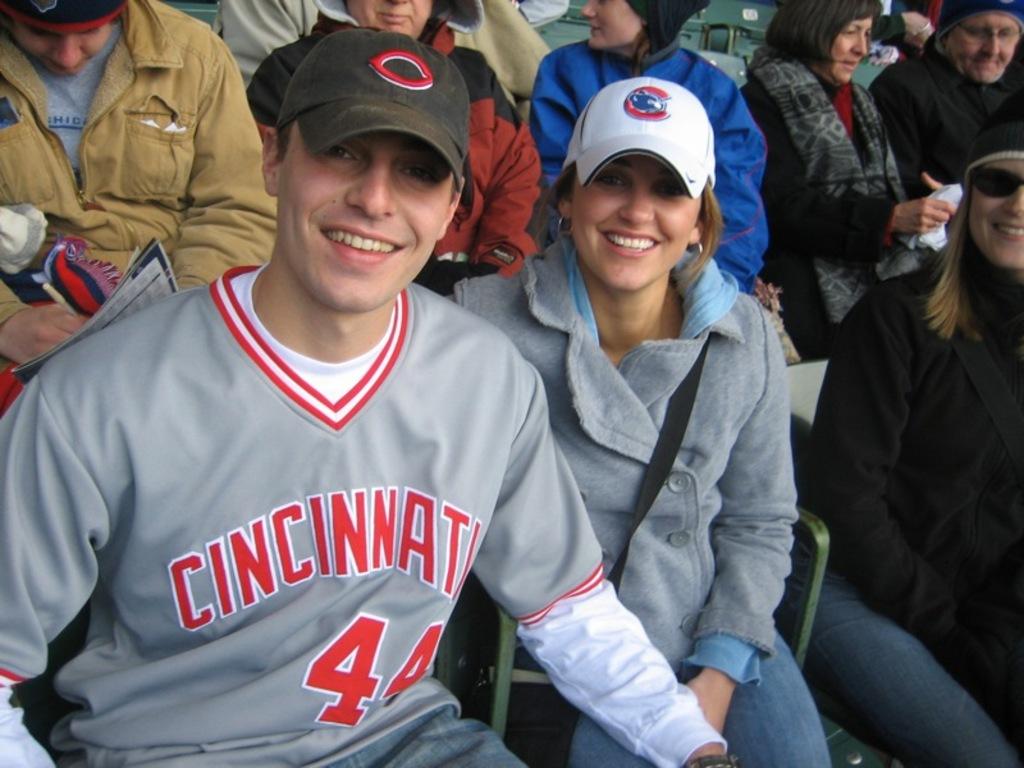Waht player number is on this man's jersey?
Keep it short and to the point. 44. What does the shirt say?
Your answer should be compact. Cincinnati. 